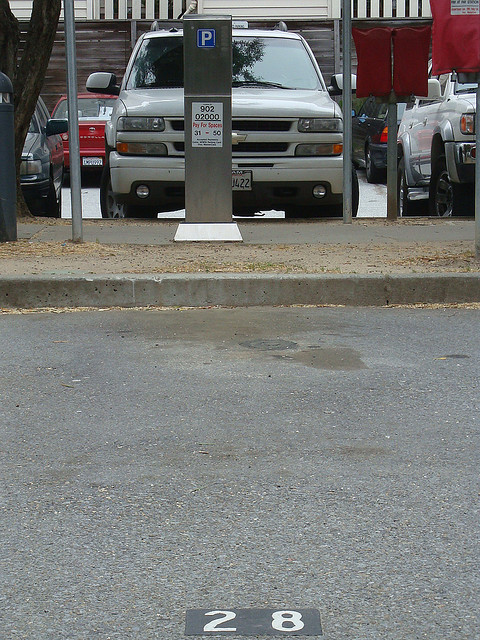What challenges might drivers face related to parking in this area? Drivers in this area could face several challenges related to parking. Given that the white truck is occupying a metered parking spot amongst several other vehicles, it indicates that finding an available parking space might be tough, particularly during busy periods. Drivers must navigate the need to pay for their parking using the provided meter, ensuring they do so correctly to avoid fines. It's also crucial for drivers to follow all parking regulations to prevent obstructing accessibility or visibility for other motorists. This could mean closely watching for specific rules and timings associated with the parking meter. Overall, drivers should remain vigilant and considerate, recognizing the high demand and limited nature of parking spaces in such areas. 